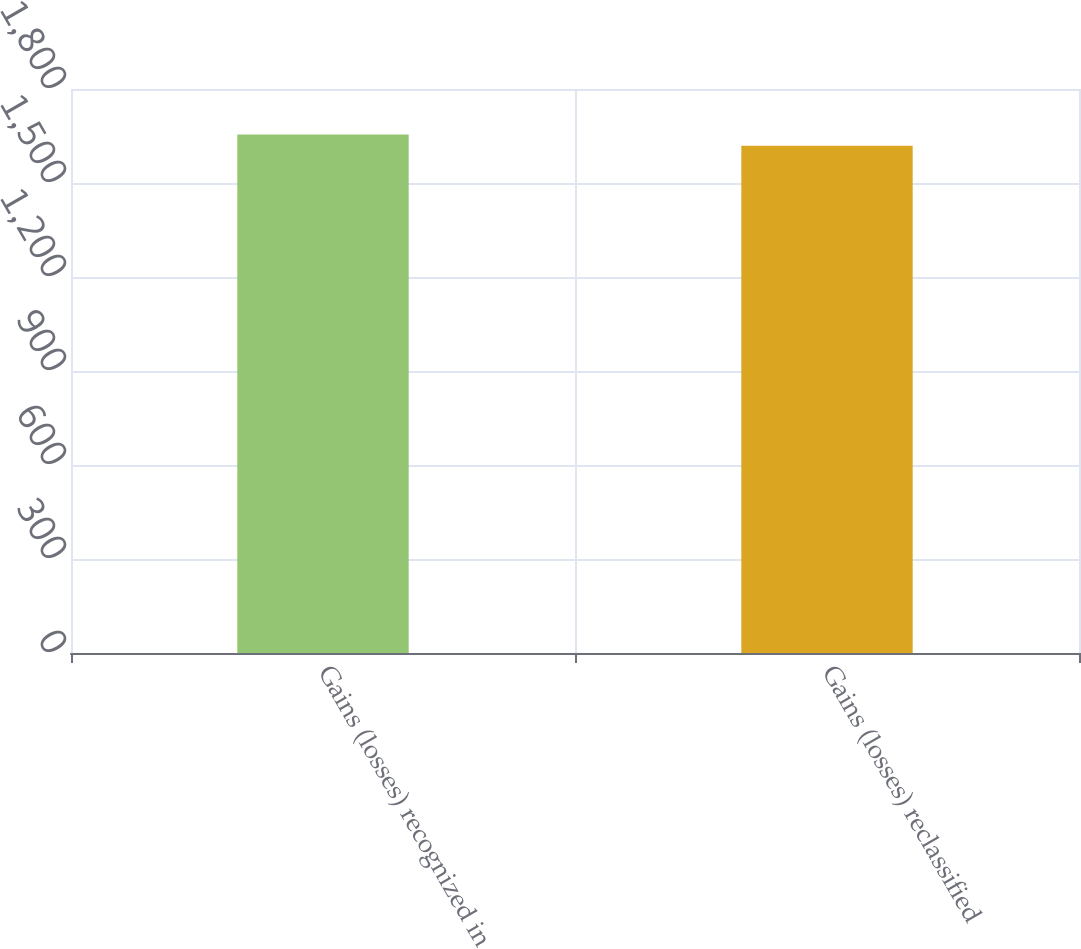Convert chart. <chart><loc_0><loc_0><loc_500><loc_500><bar_chart><fcel>Gains (losses) recognized in<fcel>Gains (losses) reclassified<nl><fcel>1655<fcel>1619<nl></chart> 